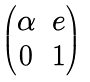Convert formula to latex. <formula><loc_0><loc_0><loc_500><loc_500>\begin{pmatrix} \alpha & e \\ 0 & 1 \\ \end{pmatrix}</formula> 